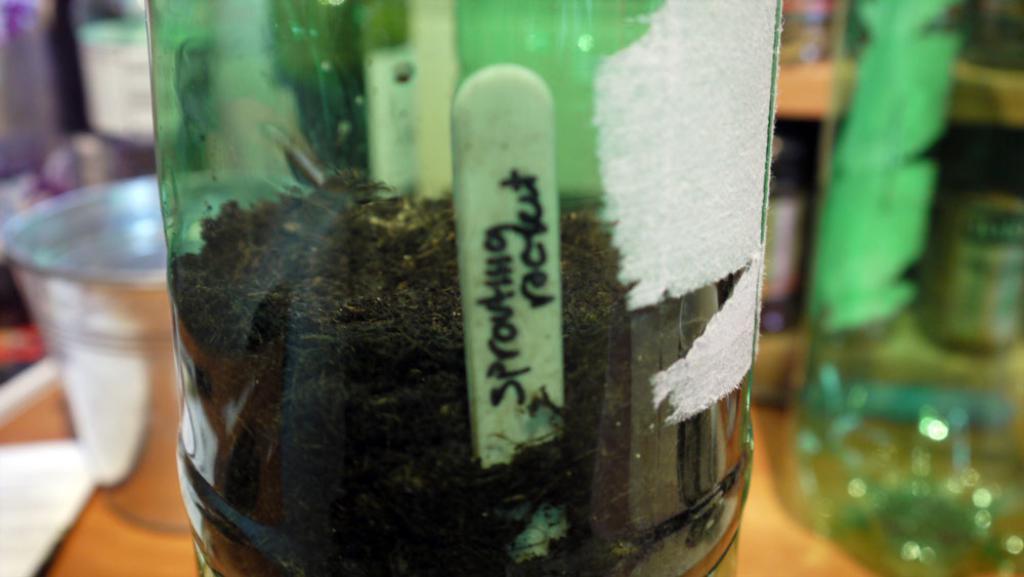How would you summarize this image in a sentence or two? Bottle wooden stick in it. 